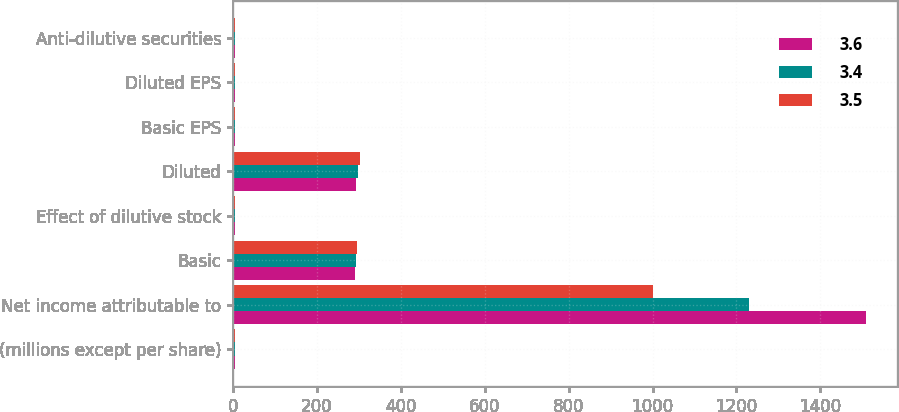<chart> <loc_0><loc_0><loc_500><loc_500><stacked_bar_chart><ecel><fcel>(millions except per share)<fcel>Net income attributable to<fcel>Basic<fcel>Effect of dilutive stock<fcel>Diluted<fcel>Basic EPS<fcel>Diluted EPS<fcel>Anti-dilutive securities<nl><fcel>3.6<fcel>5.13<fcel>1508.4<fcel>289.6<fcel>4.4<fcel>294<fcel>5.21<fcel>5.13<fcel>3.4<nl><fcel>3.4<fcel>5.13<fcel>1229.6<fcel>292.5<fcel>4.2<fcel>296.7<fcel>4.2<fcel>4.14<fcel>3.6<nl><fcel>3.5<fcel>5.13<fcel>1002.1<fcel>296.4<fcel>5<fcel>301.4<fcel>3.38<fcel>3.32<fcel>3.5<nl></chart> 